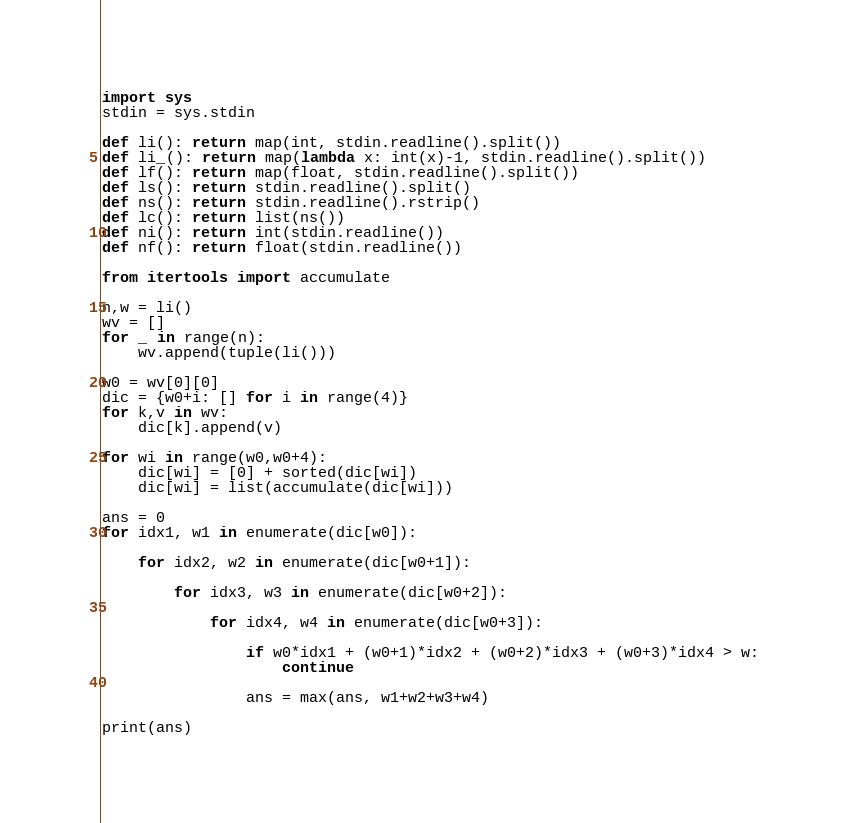Convert code to text. <code><loc_0><loc_0><loc_500><loc_500><_Python_>import sys
stdin = sys.stdin

def li(): return map(int, stdin.readline().split())
def li_(): return map(lambda x: int(x)-1, stdin.readline().split())
def lf(): return map(float, stdin.readline().split())
def ls(): return stdin.readline().split()
def ns(): return stdin.readline().rstrip()
def lc(): return list(ns())
def ni(): return int(stdin.readline())
def nf(): return float(stdin.readline())

from itertools import accumulate

n,w = li()
wv = []
for _ in range(n):
    wv.append(tuple(li()))
    
w0 = wv[0][0]
dic = {w0+i: [] for i in range(4)}
for k,v in wv:
    dic[k].append(v)
    
for wi in range(w0,w0+4):
    dic[wi] = [0] + sorted(dic[wi])
    dic[wi] = list(accumulate(dic[wi]))
    
ans = 0
for idx1, w1 in enumerate(dic[w0]):
    
    for idx2, w2 in enumerate(dic[w0+1]):
        
        for idx3, w3 in enumerate(dic[w0+2]):
            
            for idx4, w4 in enumerate(dic[w0+3]):
                
                if w0*idx1 + (w0+1)*idx2 + (w0+2)*idx3 + (w0+3)*idx4 > w:
                    continue
                
                ans = max(ans, w1+w2+w3+w4)
        
print(ans)</code> 